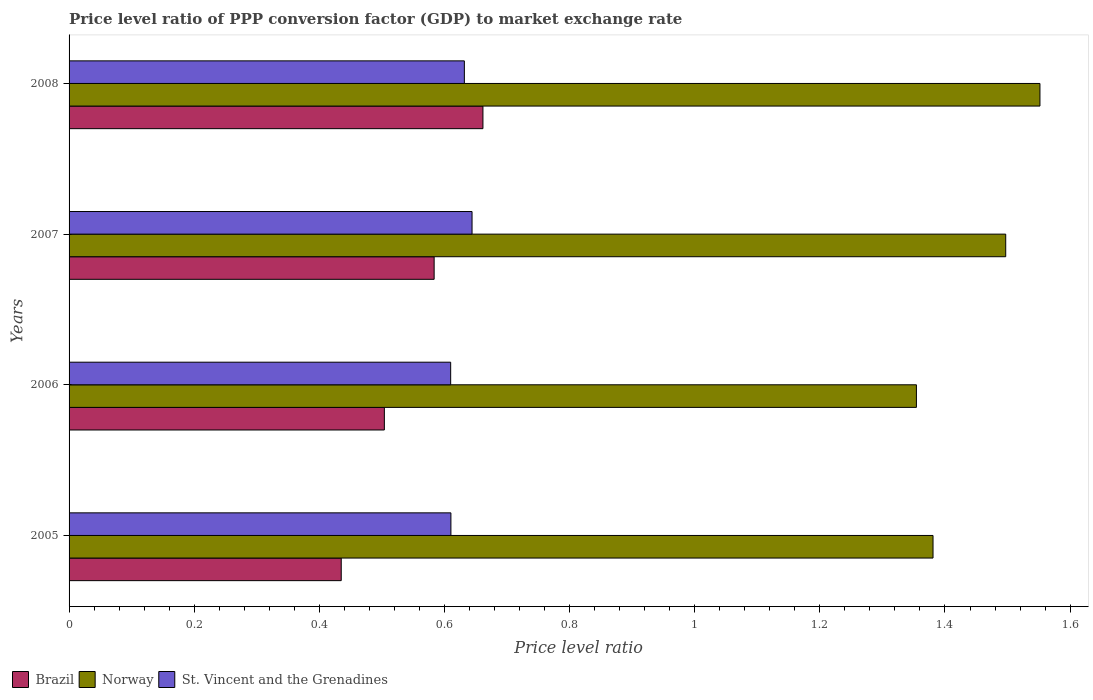How many groups of bars are there?
Provide a short and direct response. 4. Are the number of bars on each tick of the Y-axis equal?
Give a very brief answer. Yes. How many bars are there on the 1st tick from the top?
Ensure brevity in your answer.  3. How many bars are there on the 3rd tick from the bottom?
Offer a very short reply. 3. In how many cases, is the number of bars for a given year not equal to the number of legend labels?
Keep it short and to the point. 0. What is the price level ratio in Brazil in 2006?
Offer a very short reply. 0.5. Across all years, what is the maximum price level ratio in Norway?
Give a very brief answer. 1.55. Across all years, what is the minimum price level ratio in Norway?
Make the answer very short. 1.35. What is the total price level ratio in Norway in the graph?
Provide a short and direct response. 5.78. What is the difference between the price level ratio in Norway in 2007 and that in 2008?
Ensure brevity in your answer.  -0.05. What is the difference between the price level ratio in St. Vincent and the Grenadines in 2006 and the price level ratio in Brazil in 2008?
Give a very brief answer. -0.05. What is the average price level ratio in Brazil per year?
Ensure brevity in your answer.  0.55. In the year 2008, what is the difference between the price level ratio in Brazil and price level ratio in Norway?
Make the answer very short. -0.89. What is the ratio of the price level ratio in Brazil in 2005 to that in 2006?
Provide a short and direct response. 0.86. Is the price level ratio in Brazil in 2005 less than that in 2006?
Your answer should be compact. Yes. What is the difference between the highest and the second highest price level ratio in St. Vincent and the Grenadines?
Provide a short and direct response. 0.01. What is the difference between the highest and the lowest price level ratio in Norway?
Ensure brevity in your answer.  0.2. What does the 3rd bar from the top in 2006 represents?
Ensure brevity in your answer.  Brazil. What does the 1st bar from the bottom in 2006 represents?
Ensure brevity in your answer.  Brazil. Is it the case that in every year, the sum of the price level ratio in Norway and price level ratio in St. Vincent and the Grenadines is greater than the price level ratio in Brazil?
Ensure brevity in your answer.  Yes. Are all the bars in the graph horizontal?
Your answer should be compact. Yes. How many years are there in the graph?
Make the answer very short. 4. What is the difference between two consecutive major ticks on the X-axis?
Offer a very short reply. 0.2. Where does the legend appear in the graph?
Provide a succinct answer. Bottom left. What is the title of the graph?
Keep it short and to the point. Price level ratio of PPP conversion factor (GDP) to market exchange rate. Does "Tanzania" appear as one of the legend labels in the graph?
Your response must be concise. No. What is the label or title of the X-axis?
Your answer should be very brief. Price level ratio. What is the Price level ratio of Brazil in 2005?
Your response must be concise. 0.44. What is the Price level ratio in Norway in 2005?
Make the answer very short. 1.38. What is the Price level ratio of St. Vincent and the Grenadines in 2005?
Your answer should be compact. 0.61. What is the Price level ratio in Brazil in 2006?
Your response must be concise. 0.5. What is the Price level ratio of Norway in 2006?
Make the answer very short. 1.35. What is the Price level ratio of St. Vincent and the Grenadines in 2006?
Offer a terse response. 0.61. What is the Price level ratio in Brazil in 2007?
Your answer should be very brief. 0.58. What is the Price level ratio of Norway in 2007?
Provide a succinct answer. 1.5. What is the Price level ratio of St. Vincent and the Grenadines in 2007?
Give a very brief answer. 0.64. What is the Price level ratio in Brazil in 2008?
Give a very brief answer. 0.66. What is the Price level ratio of Norway in 2008?
Provide a succinct answer. 1.55. What is the Price level ratio of St. Vincent and the Grenadines in 2008?
Offer a very short reply. 0.63. Across all years, what is the maximum Price level ratio of Brazil?
Your answer should be compact. 0.66. Across all years, what is the maximum Price level ratio of Norway?
Provide a short and direct response. 1.55. Across all years, what is the maximum Price level ratio of St. Vincent and the Grenadines?
Provide a short and direct response. 0.64. Across all years, what is the minimum Price level ratio of Brazil?
Your answer should be very brief. 0.44. Across all years, what is the minimum Price level ratio in Norway?
Provide a short and direct response. 1.35. Across all years, what is the minimum Price level ratio in St. Vincent and the Grenadines?
Make the answer very short. 0.61. What is the total Price level ratio of Brazil in the graph?
Offer a terse response. 2.18. What is the total Price level ratio in Norway in the graph?
Make the answer very short. 5.78. What is the total Price level ratio of St. Vincent and the Grenadines in the graph?
Offer a terse response. 2.5. What is the difference between the Price level ratio in Brazil in 2005 and that in 2006?
Your answer should be very brief. -0.07. What is the difference between the Price level ratio in Norway in 2005 and that in 2006?
Ensure brevity in your answer.  0.03. What is the difference between the Price level ratio in St. Vincent and the Grenadines in 2005 and that in 2006?
Offer a very short reply. 0. What is the difference between the Price level ratio of Brazil in 2005 and that in 2007?
Offer a very short reply. -0.15. What is the difference between the Price level ratio in Norway in 2005 and that in 2007?
Ensure brevity in your answer.  -0.12. What is the difference between the Price level ratio of St. Vincent and the Grenadines in 2005 and that in 2007?
Give a very brief answer. -0.03. What is the difference between the Price level ratio in Brazil in 2005 and that in 2008?
Provide a short and direct response. -0.23. What is the difference between the Price level ratio in Norway in 2005 and that in 2008?
Offer a terse response. -0.17. What is the difference between the Price level ratio of St. Vincent and the Grenadines in 2005 and that in 2008?
Offer a very short reply. -0.02. What is the difference between the Price level ratio in Brazil in 2006 and that in 2007?
Provide a short and direct response. -0.08. What is the difference between the Price level ratio in Norway in 2006 and that in 2007?
Keep it short and to the point. -0.14. What is the difference between the Price level ratio in St. Vincent and the Grenadines in 2006 and that in 2007?
Your answer should be compact. -0.03. What is the difference between the Price level ratio in Brazil in 2006 and that in 2008?
Keep it short and to the point. -0.16. What is the difference between the Price level ratio in Norway in 2006 and that in 2008?
Keep it short and to the point. -0.2. What is the difference between the Price level ratio of St. Vincent and the Grenadines in 2006 and that in 2008?
Your response must be concise. -0.02. What is the difference between the Price level ratio in Brazil in 2007 and that in 2008?
Your answer should be compact. -0.08. What is the difference between the Price level ratio in Norway in 2007 and that in 2008?
Offer a very short reply. -0.05. What is the difference between the Price level ratio of St. Vincent and the Grenadines in 2007 and that in 2008?
Provide a succinct answer. 0.01. What is the difference between the Price level ratio of Brazil in 2005 and the Price level ratio of Norway in 2006?
Provide a short and direct response. -0.92. What is the difference between the Price level ratio of Brazil in 2005 and the Price level ratio of St. Vincent and the Grenadines in 2006?
Your response must be concise. -0.17. What is the difference between the Price level ratio in Norway in 2005 and the Price level ratio in St. Vincent and the Grenadines in 2006?
Make the answer very short. 0.77. What is the difference between the Price level ratio in Brazil in 2005 and the Price level ratio in Norway in 2007?
Offer a terse response. -1.06. What is the difference between the Price level ratio of Brazil in 2005 and the Price level ratio of St. Vincent and the Grenadines in 2007?
Ensure brevity in your answer.  -0.21. What is the difference between the Price level ratio in Norway in 2005 and the Price level ratio in St. Vincent and the Grenadines in 2007?
Provide a short and direct response. 0.74. What is the difference between the Price level ratio in Brazil in 2005 and the Price level ratio in Norway in 2008?
Give a very brief answer. -1.12. What is the difference between the Price level ratio of Brazil in 2005 and the Price level ratio of St. Vincent and the Grenadines in 2008?
Your answer should be compact. -0.2. What is the difference between the Price level ratio of Norway in 2005 and the Price level ratio of St. Vincent and the Grenadines in 2008?
Your response must be concise. 0.75. What is the difference between the Price level ratio in Brazil in 2006 and the Price level ratio in Norway in 2007?
Ensure brevity in your answer.  -0.99. What is the difference between the Price level ratio of Brazil in 2006 and the Price level ratio of St. Vincent and the Grenadines in 2007?
Ensure brevity in your answer.  -0.14. What is the difference between the Price level ratio of Norway in 2006 and the Price level ratio of St. Vincent and the Grenadines in 2007?
Provide a succinct answer. 0.71. What is the difference between the Price level ratio of Brazil in 2006 and the Price level ratio of Norway in 2008?
Offer a terse response. -1.05. What is the difference between the Price level ratio of Brazil in 2006 and the Price level ratio of St. Vincent and the Grenadines in 2008?
Provide a succinct answer. -0.13. What is the difference between the Price level ratio of Norway in 2006 and the Price level ratio of St. Vincent and the Grenadines in 2008?
Offer a terse response. 0.72. What is the difference between the Price level ratio in Brazil in 2007 and the Price level ratio in Norway in 2008?
Offer a very short reply. -0.97. What is the difference between the Price level ratio in Brazil in 2007 and the Price level ratio in St. Vincent and the Grenadines in 2008?
Offer a very short reply. -0.05. What is the difference between the Price level ratio of Norway in 2007 and the Price level ratio of St. Vincent and the Grenadines in 2008?
Keep it short and to the point. 0.87. What is the average Price level ratio in Brazil per year?
Make the answer very short. 0.55. What is the average Price level ratio of Norway per year?
Make the answer very short. 1.45. What is the average Price level ratio of St. Vincent and the Grenadines per year?
Ensure brevity in your answer.  0.62. In the year 2005, what is the difference between the Price level ratio of Brazil and Price level ratio of Norway?
Provide a succinct answer. -0.95. In the year 2005, what is the difference between the Price level ratio of Brazil and Price level ratio of St. Vincent and the Grenadines?
Ensure brevity in your answer.  -0.18. In the year 2005, what is the difference between the Price level ratio in Norway and Price level ratio in St. Vincent and the Grenadines?
Your answer should be very brief. 0.77. In the year 2006, what is the difference between the Price level ratio of Brazil and Price level ratio of Norway?
Give a very brief answer. -0.85. In the year 2006, what is the difference between the Price level ratio of Brazil and Price level ratio of St. Vincent and the Grenadines?
Give a very brief answer. -0.11. In the year 2006, what is the difference between the Price level ratio in Norway and Price level ratio in St. Vincent and the Grenadines?
Make the answer very short. 0.74. In the year 2007, what is the difference between the Price level ratio in Brazil and Price level ratio in Norway?
Make the answer very short. -0.91. In the year 2007, what is the difference between the Price level ratio of Brazil and Price level ratio of St. Vincent and the Grenadines?
Your answer should be compact. -0.06. In the year 2007, what is the difference between the Price level ratio in Norway and Price level ratio in St. Vincent and the Grenadines?
Offer a very short reply. 0.85. In the year 2008, what is the difference between the Price level ratio of Brazil and Price level ratio of Norway?
Keep it short and to the point. -0.89. In the year 2008, what is the difference between the Price level ratio in Brazil and Price level ratio in St. Vincent and the Grenadines?
Keep it short and to the point. 0.03. In the year 2008, what is the difference between the Price level ratio in Norway and Price level ratio in St. Vincent and the Grenadines?
Offer a terse response. 0.92. What is the ratio of the Price level ratio of Brazil in 2005 to that in 2006?
Offer a terse response. 0.86. What is the ratio of the Price level ratio in Norway in 2005 to that in 2006?
Keep it short and to the point. 1.02. What is the ratio of the Price level ratio in St. Vincent and the Grenadines in 2005 to that in 2006?
Offer a terse response. 1. What is the ratio of the Price level ratio of Brazil in 2005 to that in 2007?
Provide a short and direct response. 0.75. What is the ratio of the Price level ratio in Norway in 2005 to that in 2007?
Give a very brief answer. 0.92. What is the ratio of the Price level ratio in St. Vincent and the Grenadines in 2005 to that in 2007?
Ensure brevity in your answer.  0.95. What is the ratio of the Price level ratio of Brazil in 2005 to that in 2008?
Provide a short and direct response. 0.66. What is the ratio of the Price level ratio in Norway in 2005 to that in 2008?
Your response must be concise. 0.89. What is the ratio of the Price level ratio in St. Vincent and the Grenadines in 2005 to that in 2008?
Your response must be concise. 0.97. What is the ratio of the Price level ratio in Brazil in 2006 to that in 2007?
Give a very brief answer. 0.86. What is the ratio of the Price level ratio of Norway in 2006 to that in 2007?
Offer a very short reply. 0.9. What is the ratio of the Price level ratio in St. Vincent and the Grenadines in 2006 to that in 2007?
Ensure brevity in your answer.  0.95. What is the ratio of the Price level ratio of Brazil in 2006 to that in 2008?
Provide a succinct answer. 0.76. What is the ratio of the Price level ratio in Norway in 2006 to that in 2008?
Provide a short and direct response. 0.87. What is the ratio of the Price level ratio of St. Vincent and the Grenadines in 2006 to that in 2008?
Ensure brevity in your answer.  0.97. What is the ratio of the Price level ratio in Brazil in 2007 to that in 2008?
Your answer should be very brief. 0.88. What is the ratio of the Price level ratio in Norway in 2007 to that in 2008?
Provide a succinct answer. 0.96. What is the ratio of the Price level ratio of St. Vincent and the Grenadines in 2007 to that in 2008?
Your answer should be very brief. 1.02. What is the difference between the highest and the second highest Price level ratio in Brazil?
Your response must be concise. 0.08. What is the difference between the highest and the second highest Price level ratio in Norway?
Ensure brevity in your answer.  0.05. What is the difference between the highest and the second highest Price level ratio of St. Vincent and the Grenadines?
Ensure brevity in your answer.  0.01. What is the difference between the highest and the lowest Price level ratio in Brazil?
Ensure brevity in your answer.  0.23. What is the difference between the highest and the lowest Price level ratio of Norway?
Your response must be concise. 0.2. What is the difference between the highest and the lowest Price level ratio of St. Vincent and the Grenadines?
Ensure brevity in your answer.  0.03. 